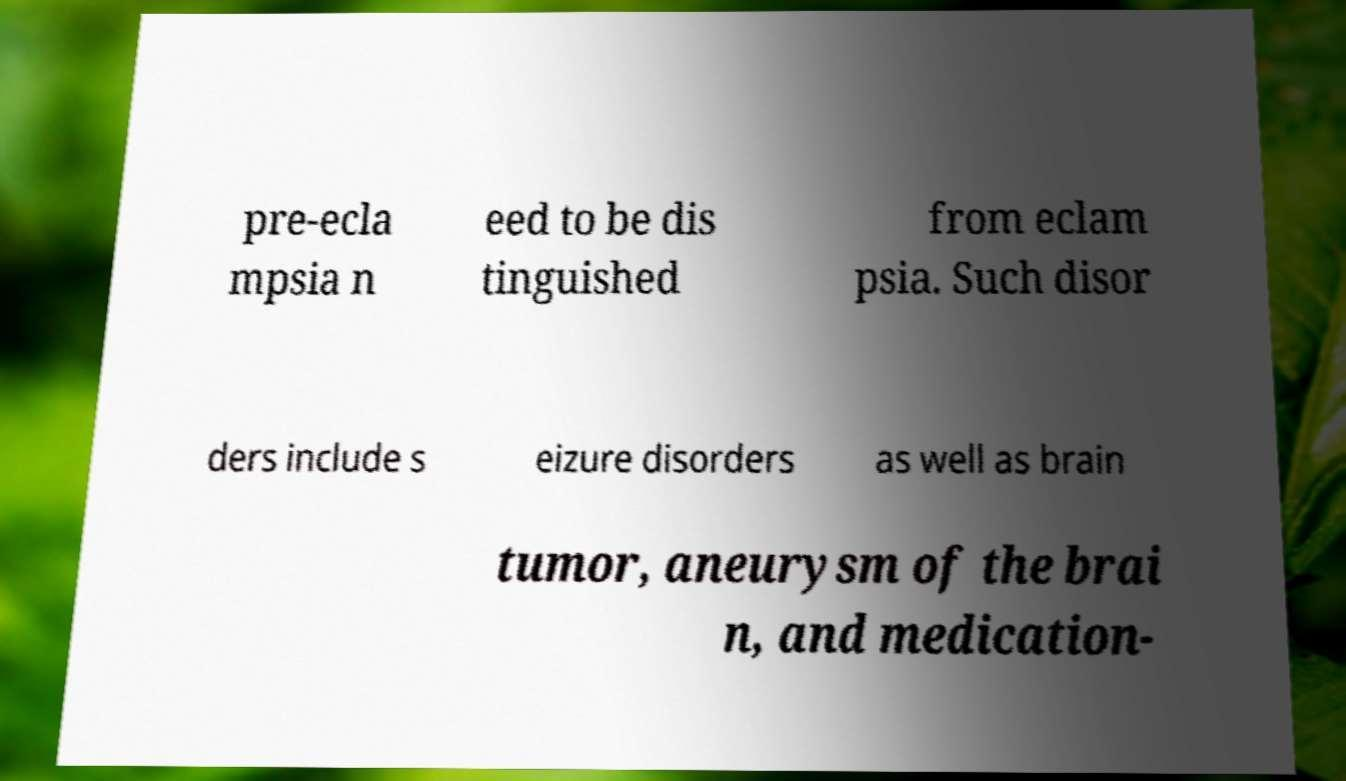For documentation purposes, I need the text within this image transcribed. Could you provide that? pre-ecla mpsia n eed to be dis tinguished from eclam psia. Such disor ders include s eizure disorders as well as brain tumor, aneurysm of the brai n, and medication- 